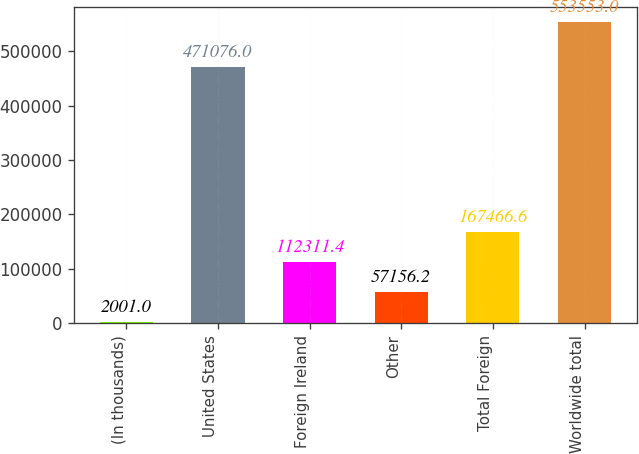<chart> <loc_0><loc_0><loc_500><loc_500><bar_chart><fcel>(In thousands)<fcel>United States<fcel>Foreign Ireland<fcel>Other<fcel>Total Foreign<fcel>Worldwide total<nl><fcel>2001<fcel>471076<fcel>112311<fcel>57156.2<fcel>167467<fcel>553553<nl></chart> 